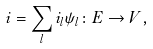<formula> <loc_0><loc_0><loc_500><loc_500>i = \sum _ { l } i _ { l } \psi _ { l } \colon E \rightarrow V ,</formula> 